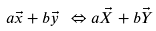<formula> <loc_0><loc_0><loc_500><loc_500>a \vec { x } + b \vec { y } \ \Leftrightarrow a \vec { X } + b \vec { Y }</formula> 